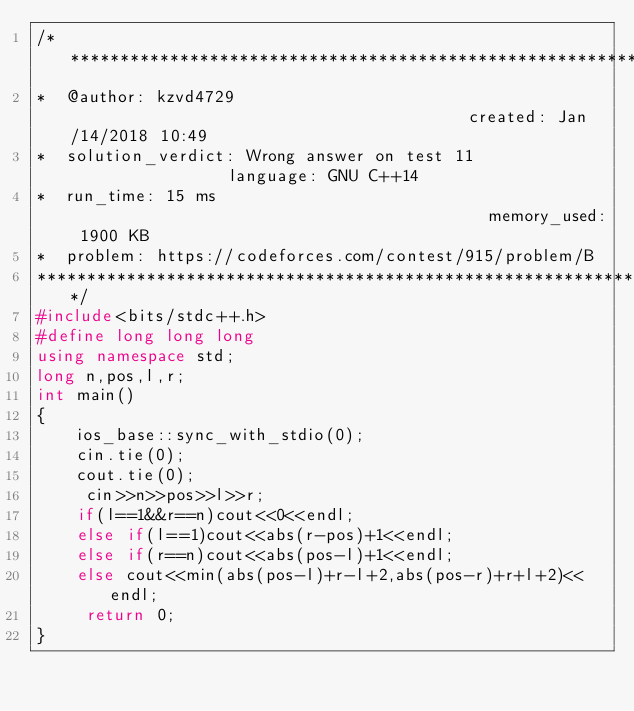<code> <loc_0><loc_0><loc_500><loc_500><_C++_>/****************************************************************************************
*  @author: kzvd4729                                         created: Jan/14/2018 10:49                        
*  solution_verdict: Wrong answer on test 11                 language: GNU C++14                               
*  run_time: 15 ms                                           memory_used: 1900 KB                              
*  problem: https://codeforces.com/contest/915/problem/B
****************************************************************************************/
#include<bits/stdc++.h>
#define long long long
using namespace std;
long n,pos,l,r;
int main()
{
    ios_base::sync_with_stdio(0);
    cin.tie(0);
    cout.tie(0);
     cin>>n>>pos>>l>>r;
    if(l==1&&r==n)cout<<0<<endl;
    else if(l==1)cout<<abs(r-pos)+1<<endl;
    else if(r==n)cout<<abs(pos-l)+1<<endl;
    else cout<<min(abs(pos-l)+r-l+2,abs(pos-r)+r+l+2)<<endl;
     return 0;
}</code> 